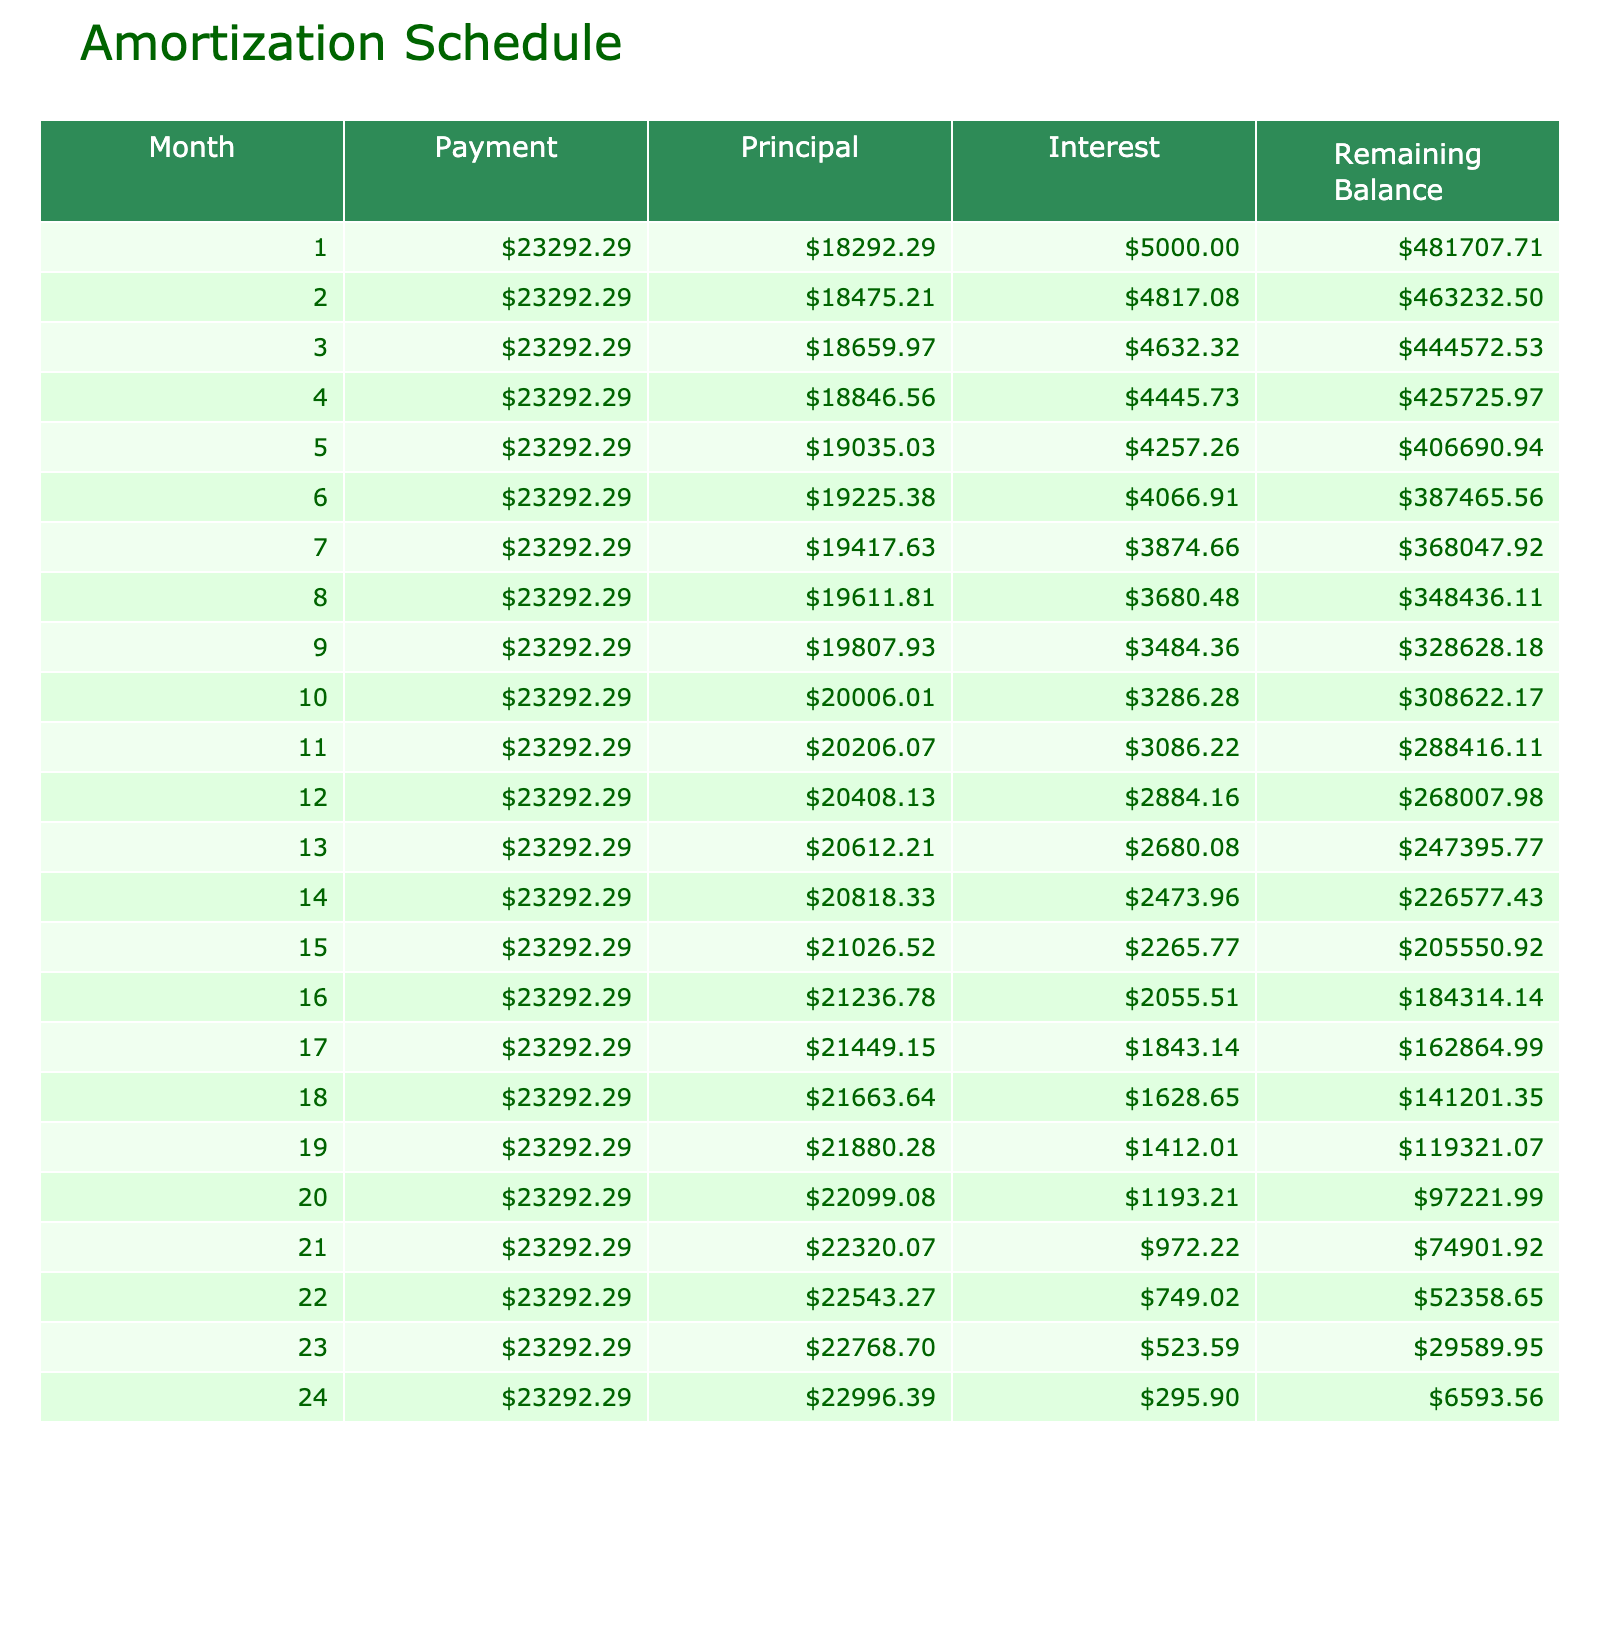What is the initial loan amount? The initial loan amount for the business is clearly stated in the table as $500,000.
Answer: $500,000 How much is the monthly payment? The monthly payment is listed directly in the table and shows a value of $23,292.29.
Answer: $23,292.29 What is the total interest paid over the loan term? In the table, the total interest paid is mentioned as $50,906.94, which reflects the cumulative amount of interest that will be paid over the duration of the loan.
Answer: $50,906.94 How much will be paid in total by the end of the loan? The total payment amount can be found in the table, which indicates the sum of the principal and interest payments at $550,906.94.
Answer: $550,906.94 Is the loan term more than 12 months? The term listed in the table is 24 months, hence it exceeds 12 months, making this statement true.
Answer: Yes What is the remaining balance after 6 months? To find the remaining balance after 6 months, we would consider the monthly payments and apply the amortization logic. After calculating for 6 months, we find the current balance to be approximately $266,222.57, which is derived from maintaining the scheduled deductions from the original amount.
Answer: $266,222.57 What is the total principal paid by the end of the first year? To calculate the total principal paid by the end of the first year, we need to sum the principal payments for the first 12 months. Each month, a portion of the monthly payment goes towards the principal. By accumulating this over 12 months, we find that the total principal paid by the end of the first year is approximately $235,000.
Answer: $235,000 Is the interest payment less than the principal payment in the first month? The first month’s interest payment can be calculated as 12% of the loan divided by 12, which is $5,000. The total monthly payment is $23,292.29, and subtracting the interest from this gives a principal payment of $18,292.29. Since $18,292.29 is greater than $5,000, the statement is true.
Answer: Yes How does the principal payment change over the course of the loan? The principal payment increases each month as the balance reduces, while the interest payments decrease. Initially, the monthly principal is larger until the loan balance decreases, reflecting less interest, which results in a higher principal amount being paid later. By examining the monthly adjustments, one can see that the principal payment steadily rises.
Answer: The principal payment increases over time 